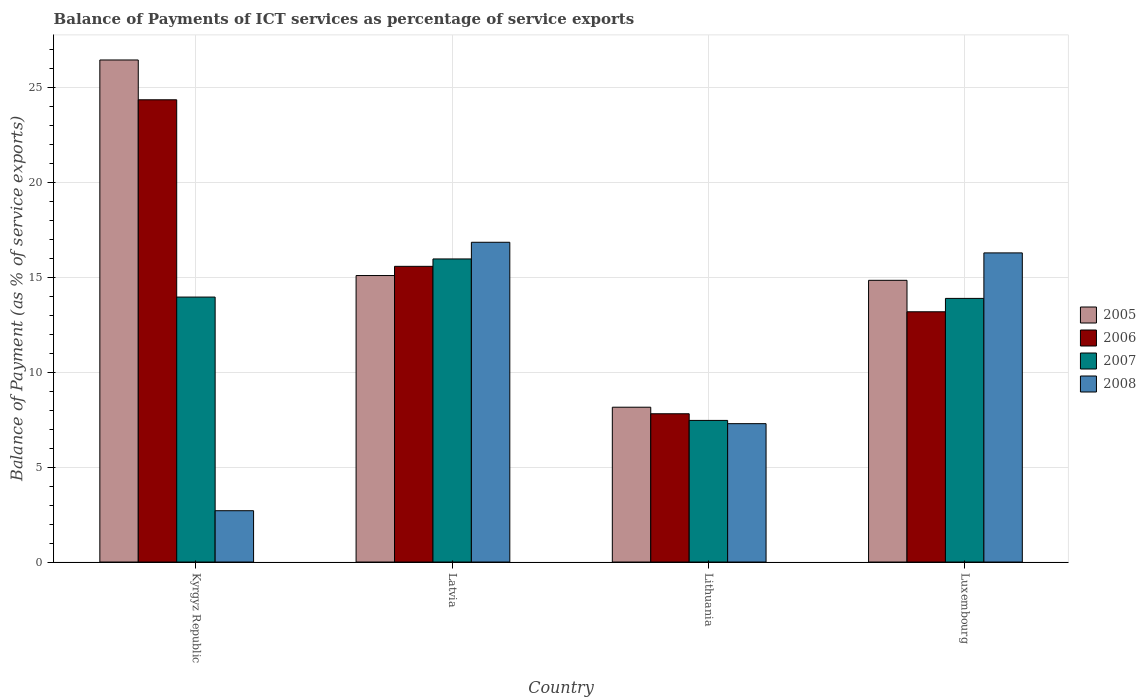How many different coloured bars are there?
Ensure brevity in your answer.  4. How many groups of bars are there?
Ensure brevity in your answer.  4. How many bars are there on the 3rd tick from the left?
Provide a short and direct response. 4. What is the label of the 1st group of bars from the left?
Provide a succinct answer. Kyrgyz Republic. What is the balance of payments of ICT services in 2007 in Lithuania?
Your answer should be very brief. 7.46. Across all countries, what is the maximum balance of payments of ICT services in 2007?
Keep it short and to the point. 15.97. Across all countries, what is the minimum balance of payments of ICT services in 2005?
Keep it short and to the point. 8.16. In which country was the balance of payments of ICT services in 2006 maximum?
Your answer should be very brief. Kyrgyz Republic. In which country was the balance of payments of ICT services in 2006 minimum?
Make the answer very short. Lithuania. What is the total balance of payments of ICT services in 2008 in the graph?
Keep it short and to the point. 43.12. What is the difference between the balance of payments of ICT services in 2007 in Kyrgyz Republic and that in Lithuania?
Your answer should be very brief. 6.5. What is the difference between the balance of payments of ICT services in 2007 in Lithuania and the balance of payments of ICT services in 2005 in Kyrgyz Republic?
Your answer should be very brief. -18.99. What is the average balance of payments of ICT services in 2008 per country?
Your answer should be very brief. 10.78. What is the difference between the balance of payments of ICT services of/in 2006 and balance of payments of ICT services of/in 2005 in Lithuania?
Ensure brevity in your answer.  -0.34. In how many countries, is the balance of payments of ICT services in 2007 greater than 26 %?
Offer a terse response. 0. What is the ratio of the balance of payments of ICT services in 2005 in Kyrgyz Republic to that in Latvia?
Make the answer very short. 1.75. Is the difference between the balance of payments of ICT services in 2006 in Kyrgyz Republic and Lithuania greater than the difference between the balance of payments of ICT services in 2005 in Kyrgyz Republic and Lithuania?
Ensure brevity in your answer.  No. What is the difference between the highest and the second highest balance of payments of ICT services in 2006?
Provide a succinct answer. 11.17. What is the difference between the highest and the lowest balance of payments of ICT services in 2007?
Offer a terse response. 8.51. In how many countries, is the balance of payments of ICT services in 2007 greater than the average balance of payments of ICT services in 2007 taken over all countries?
Give a very brief answer. 3. Is it the case that in every country, the sum of the balance of payments of ICT services in 2008 and balance of payments of ICT services in 2007 is greater than the sum of balance of payments of ICT services in 2005 and balance of payments of ICT services in 2006?
Keep it short and to the point. No. What does the 4th bar from the right in Lithuania represents?
Give a very brief answer. 2005. How many bars are there?
Make the answer very short. 16. Are all the bars in the graph horizontal?
Give a very brief answer. No. How many countries are there in the graph?
Give a very brief answer. 4. What is the difference between two consecutive major ticks on the Y-axis?
Provide a short and direct response. 5. How many legend labels are there?
Your response must be concise. 4. What is the title of the graph?
Offer a very short reply. Balance of Payments of ICT services as percentage of service exports. Does "2005" appear as one of the legend labels in the graph?
Your answer should be very brief. Yes. What is the label or title of the Y-axis?
Make the answer very short. Balance of Payment (as % of service exports). What is the Balance of Payment (as % of service exports) of 2005 in Kyrgyz Republic?
Ensure brevity in your answer.  26.45. What is the Balance of Payment (as % of service exports) in 2006 in Kyrgyz Republic?
Ensure brevity in your answer.  24.35. What is the Balance of Payment (as % of service exports) in 2007 in Kyrgyz Republic?
Your answer should be very brief. 13.96. What is the Balance of Payment (as % of service exports) of 2008 in Kyrgyz Republic?
Give a very brief answer. 2.7. What is the Balance of Payment (as % of service exports) in 2005 in Latvia?
Make the answer very short. 15.09. What is the Balance of Payment (as % of service exports) of 2006 in Latvia?
Your answer should be compact. 15.58. What is the Balance of Payment (as % of service exports) in 2007 in Latvia?
Offer a terse response. 15.97. What is the Balance of Payment (as % of service exports) in 2008 in Latvia?
Offer a terse response. 16.84. What is the Balance of Payment (as % of service exports) of 2005 in Lithuania?
Provide a short and direct response. 8.16. What is the Balance of Payment (as % of service exports) in 2006 in Lithuania?
Your response must be concise. 7.81. What is the Balance of Payment (as % of service exports) in 2007 in Lithuania?
Your answer should be very brief. 7.46. What is the Balance of Payment (as % of service exports) in 2008 in Lithuania?
Your response must be concise. 7.29. What is the Balance of Payment (as % of service exports) in 2005 in Luxembourg?
Your response must be concise. 14.84. What is the Balance of Payment (as % of service exports) of 2006 in Luxembourg?
Your response must be concise. 13.18. What is the Balance of Payment (as % of service exports) in 2007 in Luxembourg?
Offer a terse response. 13.89. What is the Balance of Payment (as % of service exports) of 2008 in Luxembourg?
Make the answer very short. 16.28. Across all countries, what is the maximum Balance of Payment (as % of service exports) of 2005?
Offer a very short reply. 26.45. Across all countries, what is the maximum Balance of Payment (as % of service exports) of 2006?
Ensure brevity in your answer.  24.35. Across all countries, what is the maximum Balance of Payment (as % of service exports) of 2007?
Give a very brief answer. 15.97. Across all countries, what is the maximum Balance of Payment (as % of service exports) in 2008?
Keep it short and to the point. 16.84. Across all countries, what is the minimum Balance of Payment (as % of service exports) of 2005?
Provide a succinct answer. 8.16. Across all countries, what is the minimum Balance of Payment (as % of service exports) of 2006?
Your response must be concise. 7.81. Across all countries, what is the minimum Balance of Payment (as % of service exports) in 2007?
Make the answer very short. 7.46. Across all countries, what is the minimum Balance of Payment (as % of service exports) of 2008?
Your answer should be compact. 2.7. What is the total Balance of Payment (as % of service exports) of 2005 in the graph?
Give a very brief answer. 64.53. What is the total Balance of Payment (as % of service exports) of 2006 in the graph?
Ensure brevity in your answer.  60.92. What is the total Balance of Payment (as % of service exports) in 2007 in the graph?
Offer a terse response. 51.27. What is the total Balance of Payment (as % of service exports) of 2008 in the graph?
Give a very brief answer. 43.12. What is the difference between the Balance of Payment (as % of service exports) in 2005 in Kyrgyz Republic and that in Latvia?
Provide a short and direct response. 11.35. What is the difference between the Balance of Payment (as % of service exports) of 2006 in Kyrgyz Republic and that in Latvia?
Offer a terse response. 8.77. What is the difference between the Balance of Payment (as % of service exports) in 2007 in Kyrgyz Republic and that in Latvia?
Ensure brevity in your answer.  -2.01. What is the difference between the Balance of Payment (as % of service exports) in 2008 in Kyrgyz Republic and that in Latvia?
Your response must be concise. -14.14. What is the difference between the Balance of Payment (as % of service exports) in 2005 in Kyrgyz Republic and that in Lithuania?
Your answer should be compact. 18.29. What is the difference between the Balance of Payment (as % of service exports) of 2006 in Kyrgyz Republic and that in Lithuania?
Your answer should be compact. 16.54. What is the difference between the Balance of Payment (as % of service exports) in 2007 in Kyrgyz Republic and that in Lithuania?
Provide a short and direct response. 6.5. What is the difference between the Balance of Payment (as % of service exports) in 2008 in Kyrgyz Republic and that in Lithuania?
Keep it short and to the point. -4.59. What is the difference between the Balance of Payment (as % of service exports) of 2005 in Kyrgyz Republic and that in Luxembourg?
Your response must be concise. 11.61. What is the difference between the Balance of Payment (as % of service exports) of 2006 in Kyrgyz Republic and that in Luxembourg?
Offer a very short reply. 11.17. What is the difference between the Balance of Payment (as % of service exports) in 2007 in Kyrgyz Republic and that in Luxembourg?
Your answer should be very brief. 0.07. What is the difference between the Balance of Payment (as % of service exports) in 2008 in Kyrgyz Republic and that in Luxembourg?
Offer a terse response. -13.58. What is the difference between the Balance of Payment (as % of service exports) in 2005 in Latvia and that in Lithuania?
Keep it short and to the point. 6.94. What is the difference between the Balance of Payment (as % of service exports) of 2006 in Latvia and that in Lithuania?
Offer a very short reply. 7.77. What is the difference between the Balance of Payment (as % of service exports) in 2007 in Latvia and that in Lithuania?
Your answer should be compact. 8.51. What is the difference between the Balance of Payment (as % of service exports) in 2008 in Latvia and that in Lithuania?
Your response must be concise. 9.55. What is the difference between the Balance of Payment (as % of service exports) in 2005 in Latvia and that in Luxembourg?
Make the answer very short. 0.25. What is the difference between the Balance of Payment (as % of service exports) of 2006 in Latvia and that in Luxembourg?
Keep it short and to the point. 2.39. What is the difference between the Balance of Payment (as % of service exports) of 2007 in Latvia and that in Luxembourg?
Your response must be concise. 2.08. What is the difference between the Balance of Payment (as % of service exports) of 2008 in Latvia and that in Luxembourg?
Your response must be concise. 0.56. What is the difference between the Balance of Payment (as % of service exports) in 2005 in Lithuania and that in Luxembourg?
Keep it short and to the point. -6.68. What is the difference between the Balance of Payment (as % of service exports) in 2006 in Lithuania and that in Luxembourg?
Your answer should be very brief. -5.37. What is the difference between the Balance of Payment (as % of service exports) of 2007 in Lithuania and that in Luxembourg?
Provide a succinct answer. -6.43. What is the difference between the Balance of Payment (as % of service exports) in 2008 in Lithuania and that in Luxembourg?
Your response must be concise. -8.99. What is the difference between the Balance of Payment (as % of service exports) of 2005 in Kyrgyz Republic and the Balance of Payment (as % of service exports) of 2006 in Latvia?
Your answer should be very brief. 10.87. What is the difference between the Balance of Payment (as % of service exports) in 2005 in Kyrgyz Republic and the Balance of Payment (as % of service exports) in 2007 in Latvia?
Your answer should be compact. 10.48. What is the difference between the Balance of Payment (as % of service exports) of 2005 in Kyrgyz Republic and the Balance of Payment (as % of service exports) of 2008 in Latvia?
Your answer should be compact. 9.6. What is the difference between the Balance of Payment (as % of service exports) in 2006 in Kyrgyz Republic and the Balance of Payment (as % of service exports) in 2007 in Latvia?
Provide a succinct answer. 8.38. What is the difference between the Balance of Payment (as % of service exports) of 2006 in Kyrgyz Republic and the Balance of Payment (as % of service exports) of 2008 in Latvia?
Ensure brevity in your answer.  7.51. What is the difference between the Balance of Payment (as % of service exports) of 2007 in Kyrgyz Republic and the Balance of Payment (as % of service exports) of 2008 in Latvia?
Ensure brevity in your answer.  -2.89. What is the difference between the Balance of Payment (as % of service exports) of 2005 in Kyrgyz Republic and the Balance of Payment (as % of service exports) of 2006 in Lithuania?
Offer a terse response. 18.64. What is the difference between the Balance of Payment (as % of service exports) of 2005 in Kyrgyz Republic and the Balance of Payment (as % of service exports) of 2007 in Lithuania?
Give a very brief answer. 18.99. What is the difference between the Balance of Payment (as % of service exports) in 2005 in Kyrgyz Republic and the Balance of Payment (as % of service exports) in 2008 in Lithuania?
Provide a succinct answer. 19.16. What is the difference between the Balance of Payment (as % of service exports) of 2006 in Kyrgyz Republic and the Balance of Payment (as % of service exports) of 2007 in Lithuania?
Keep it short and to the point. 16.89. What is the difference between the Balance of Payment (as % of service exports) of 2006 in Kyrgyz Republic and the Balance of Payment (as % of service exports) of 2008 in Lithuania?
Provide a succinct answer. 17.06. What is the difference between the Balance of Payment (as % of service exports) of 2007 in Kyrgyz Republic and the Balance of Payment (as % of service exports) of 2008 in Lithuania?
Make the answer very short. 6.67. What is the difference between the Balance of Payment (as % of service exports) in 2005 in Kyrgyz Republic and the Balance of Payment (as % of service exports) in 2006 in Luxembourg?
Make the answer very short. 13.26. What is the difference between the Balance of Payment (as % of service exports) of 2005 in Kyrgyz Republic and the Balance of Payment (as % of service exports) of 2007 in Luxembourg?
Your response must be concise. 12.56. What is the difference between the Balance of Payment (as % of service exports) of 2005 in Kyrgyz Republic and the Balance of Payment (as % of service exports) of 2008 in Luxembourg?
Provide a succinct answer. 10.16. What is the difference between the Balance of Payment (as % of service exports) of 2006 in Kyrgyz Republic and the Balance of Payment (as % of service exports) of 2007 in Luxembourg?
Offer a terse response. 10.46. What is the difference between the Balance of Payment (as % of service exports) of 2006 in Kyrgyz Republic and the Balance of Payment (as % of service exports) of 2008 in Luxembourg?
Make the answer very short. 8.07. What is the difference between the Balance of Payment (as % of service exports) of 2007 in Kyrgyz Republic and the Balance of Payment (as % of service exports) of 2008 in Luxembourg?
Offer a terse response. -2.33. What is the difference between the Balance of Payment (as % of service exports) of 2005 in Latvia and the Balance of Payment (as % of service exports) of 2006 in Lithuania?
Make the answer very short. 7.28. What is the difference between the Balance of Payment (as % of service exports) of 2005 in Latvia and the Balance of Payment (as % of service exports) of 2007 in Lithuania?
Provide a short and direct response. 7.63. What is the difference between the Balance of Payment (as % of service exports) in 2005 in Latvia and the Balance of Payment (as % of service exports) in 2008 in Lithuania?
Your answer should be compact. 7.8. What is the difference between the Balance of Payment (as % of service exports) of 2006 in Latvia and the Balance of Payment (as % of service exports) of 2007 in Lithuania?
Keep it short and to the point. 8.12. What is the difference between the Balance of Payment (as % of service exports) of 2006 in Latvia and the Balance of Payment (as % of service exports) of 2008 in Lithuania?
Make the answer very short. 8.29. What is the difference between the Balance of Payment (as % of service exports) in 2007 in Latvia and the Balance of Payment (as % of service exports) in 2008 in Lithuania?
Offer a very short reply. 8.68. What is the difference between the Balance of Payment (as % of service exports) of 2005 in Latvia and the Balance of Payment (as % of service exports) of 2006 in Luxembourg?
Your response must be concise. 1.91. What is the difference between the Balance of Payment (as % of service exports) in 2005 in Latvia and the Balance of Payment (as % of service exports) in 2007 in Luxembourg?
Give a very brief answer. 1.2. What is the difference between the Balance of Payment (as % of service exports) in 2005 in Latvia and the Balance of Payment (as % of service exports) in 2008 in Luxembourg?
Your response must be concise. -1.19. What is the difference between the Balance of Payment (as % of service exports) in 2006 in Latvia and the Balance of Payment (as % of service exports) in 2007 in Luxembourg?
Your response must be concise. 1.69. What is the difference between the Balance of Payment (as % of service exports) of 2006 in Latvia and the Balance of Payment (as % of service exports) of 2008 in Luxembourg?
Your answer should be very brief. -0.71. What is the difference between the Balance of Payment (as % of service exports) of 2007 in Latvia and the Balance of Payment (as % of service exports) of 2008 in Luxembourg?
Your answer should be very brief. -0.32. What is the difference between the Balance of Payment (as % of service exports) of 2005 in Lithuania and the Balance of Payment (as % of service exports) of 2006 in Luxembourg?
Provide a short and direct response. -5.03. What is the difference between the Balance of Payment (as % of service exports) of 2005 in Lithuania and the Balance of Payment (as % of service exports) of 2007 in Luxembourg?
Offer a terse response. -5.73. What is the difference between the Balance of Payment (as % of service exports) of 2005 in Lithuania and the Balance of Payment (as % of service exports) of 2008 in Luxembourg?
Give a very brief answer. -8.13. What is the difference between the Balance of Payment (as % of service exports) in 2006 in Lithuania and the Balance of Payment (as % of service exports) in 2007 in Luxembourg?
Ensure brevity in your answer.  -6.08. What is the difference between the Balance of Payment (as % of service exports) of 2006 in Lithuania and the Balance of Payment (as % of service exports) of 2008 in Luxembourg?
Your answer should be very brief. -8.47. What is the difference between the Balance of Payment (as % of service exports) in 2007 in Lithuania and the Balance of Payment (as % of service exports) in 2008 in Luxembourg?
Make the answer very short. -8.82. What is the average Balance of Payment (as % of service exports) of 2005 per country?
Provide a succinct answer. 16.13. What is the average Balance of Payment (as % of service exports) of 2006 per country?
Ensure brevity in your answer.  15.23. What is the average Balance of Payment (as % of service exports) in 2007 per country?
Your answer should be compact. 12.82. What is the average Balance of Payment (as % of service exports) in 2008 per country?
Offer a very short reply. 10.78. What is the difference between the Balance of Payment (as % of service exports) in 2005 and Balance of Payment (as % of service exports) in 2006 in Kyrgyz Republic?
Offer a very short reply. 2.1. What is the difference between the Balance of Payment (as % of service exports) in 2005 and Balance of Payment (as % of service exports) in 2007 in Kyrgyz Republic?
Offer a very short reply. 12.49. What is the difference between the Balance of Payment (as % of service exports) of 2005 and Balance of Payment (as % of service exports) of 2008 in Kyrgyz Republic?
Make the answer very short. 23.74. What is the difference between the Balance of Payment (as % of service exports) in 2006 and Balance of Payment (as % of service exports) in 2007 in Kyrgyz Republic?
Keep it short and to the point. 10.39. What is the difference between the Balance of Payment (as % of service exports) of 2006 and Balance of Payment (as % of service exports) of 2008 in Kyrgyz Republic?
Your answer should be very brief. 21.65. What is the difference between the Balance of Payment (as % of service exports) of 2007 and Balance of Payment (as % of service exports) of 2008 in Kyrgyz Republic?
Ensure brevity in your answer.  11.25. What is the difference between the Balance of Payment (as % of service exports) of 2005 and Balance of Payment (as % of service exports) of 2006 in Latvia?
Offer a terse response. -0.48. What is the difference between the Balance of Payment (as % of service exports) in 2005 and Balance of Payment (as % of service exports) in 2007 in Latvia?
Ensure brevity in your answer.  -0.87. What is the difference between the Balance of Payment (as % of service exports) in 2005 and Balance of Payment (as % of service exports) in 2008 in Latvia?
Keep it short and to the point. -1.75. What is the difference between the Balance of Payment (as % of service exports) of 2006 and Balance of Payment (as % of service exports) of 2007 in Latvia?
Offer a very short reply. -0.39. What is the difference between the Balance of Payment (as % of service exports) in 2006 and Balance of Payment (as % of service exports) in 2008 in Latvia?
Ensure brevity in your answer.  -1.27. What is the difference between the Balance of Payment (as % of service exports) of 2007 and Balance of Payment (as % of service exports) of 2008 in Latvia?
Give a very brief answer. -0.88. What is the difference between the Balance of Payment (as % of service exports) of 2005 and Balance of Payment (as % of service exports) of 2006 in Lithuania?
Your answer should be very brief. 0.34. What is the difference between the Balance of Payment (as % of service exports) in 2005 and Balance of Payment (as % of service exports) in 2007 in Lithuania?
Offer a very short reply. 0.7. What is the difference between the Balance of Payment (as % of service exports) in 2005 and Balance of Payment (as % of service exports) in 2008 in Lithuania?
Provide a succinct answer. 0.87. What is the difference between the Balance of Payment (as % of service exports) in 2006 and Balance of Payment (as % of service exports) in 2007 in Lithuania?
Make the answer very short. 0.35. What is the difference between the Balance of Payment (as % of service exports) in 2006 and Balance of Payment (as % of service exports) in 2008 in Lithuania?
Make the answer very short. 0.52. What is the difference between the Balance of Payment (as % of service exports) of 2007 and Balance of Payment (as % of service exports) of 2008 in Lithuania?
Provide a succinct answer. 0.17. What is the difference between the Balance of Payment (as % of service exports) in 2005 and Balance of Payment (as % of service exports) in 2006 in Luxembourg?
Offer a very short reply. 1.66. What is the difference between the Balance of Payment (as % of service exports) in 2005 and Balance of Payment (as % of service exports) in 2007 in Luxembourg?
Your answer should be very brief. 0.95. What is the difference between the Balance of Payment (as % of service exports) in 2005 and Balance of Payment (as % of service exports) in 2008 in Luxembourg?
Offer a terse response. -1.44. What is the difference between the Balance of Payment (as % of service exports) in 2006 and Balance of Payment (as % of service exports) in 2007 in Luxembourg?
Your answer should be compact. -0.7. What is the difference between the Balance of Payment (as % of service exports) of 2006 and Balance of Payment (as % of service exports) of 2008 in Luxembourg?
Keep it short and to the point. -3.1. What is the difference between the Balance of Payment (as % of service exports) in 2007 and Balance of Payment (as % of service exports) in 2008 in Luxembourg?
Offer a very short reply. -2.4. What is the ratio of the Balance of Payment (as % of service exports) in 2005 in Kyrgyz Republic to that in Latvia?
Offer a very short reply. 1.75. What is the ratio of the Balance of Payment (as % of service exports) in 2006 in Kyrgyz Republic to that in Latvia?
Your answer should be very brief. 1.56. What is the ratio of the Balance of Payment (as % of service exports) in 2007 in Kyrgyz Republic to that in Latvia?
Your answer should be very brief. 0.87. What is the ratio of the Balance of Payment (as % of service exports) in 2008 in Kyrgyz Republic to that in Latvia?
Ensure brevity in your answer.  0.16. What is the ratio of the Balance of Payment (as % of service exports) of 2005 in Kyrgyz Republic to that in Lithuania?
Give a very brief answer. 3.24. What is the ratio of the Balance of Payment (as % of service exports) in 2006 in Kyrgyz Republic to that in Lithuania?
Offer a terse response. 3.12. What is the ratio of the Balance of Payment (as % of service exports) in 2007 in Kyrgyz Republic to that in Lithuania?
Ensure brevity in your answer.  1.87. What is the ratio of the Balance of Payment (as % of service exports) of 2008 in Kyrgyz Republic to that in Lithuania?
Keep it short and to the point. 0.37. What is the ratio of the Balance of Payment (as % of service exports) of 2005 in Kyrgyz Republic to that in Luxembourg?
Give a very brief answer. 1.78. What is the ratio of the Balance of Payment (as % of service exports) of 2006 in Kyrgyz Republic to that in Luxembourg?
Your answer should be compact. 1.85. What is the ratio of the Balance of Payment (as % of service exports) in 2007 in Kyrgyz Republic to that in Luxembourg?
Keep it short and to the point. 1. What is the ratio of the Balance of Payment (as % of service exports) in 2008 in Kyrgyz Republic to that in Luxembourg?
Offer a terse response. 0.17. What is the ratio of the Balance of Payment (as % of service exports) of 2005 in Latvia to that in Lithuania?
Offer a very short reply. 1.85. What is the ratio of the Balance of Payment (as % of service exports) of 2006 in Latvia to that in Lithuania?
Your answer should be compact. 1.99. What is the ratio of the Balance of Payment (as % of service exports) in 2007 in Latvia to that in Lithuania?
Offer a terse response. 2.14. What is the ratio of the Balance of Payment (as % of service exports) in 2008 in Latvia to that in Lithuania?
Give a very brief answer. 2.31. What is the ratio of the Balance of Payment (as % of service exports) in 2005 in Latvia to that in Luxembourg?
Provide a short and direct response. 1.02. What is the ratio of the Balance of Payment (as % of service exports) in 2006 in Latvia to that in Luxembourg?
Give a very brief answer. 1.18. What is the ratio of the Balance of Payment (as % of service exports) of 2007 in Latvia to that in Luxembourg?
Your response must be concise. 1.15. What is the ratio of the Balance of Payment (as % of service exports) of 2008 in Latvia to that in Luxembourg?
Your answer should be very brief. 1.03. What is the ratio of the Balance of Payment (as % of service exports) in 2005 in Lithuania to that in Luxembourg?
Offer a very short reply. 0.55. What is the ratio of the Balance of Payment (as % of service exports) of 2006 in Lithuania to that in Luxembourg?
Keep it short and to the point. 0.59. What is the ratio of the Balance of Payment (as % of service exports) in 2007 in Lithuania to that in Luxembourg?
Your response must be concise. 0.54. What is the ratio of the Balance of Payment (as % of service exports) in 2008 in Lithuania to that in Luxembourg?
Offer a very short reply. 0.45. What is the difference between the highest and the second highest Balance of Payment (as % of service exports) of 2005?
Ensure brevity in your answer.  11.35. What is the difference between the highest and the second highest Balance of Payment (as % of service exports) in 2006?
Offer a very short reply. 8.77. What is the difference between the highest and the second highest Balance of Payment (as % of service exports) in 2007?
Your answer should be very brief. 2.01. What is the difference between the highest and the second highest Balance of Payment (as % of service exports) of 2008?
Offer a terse response. 0.56. What is the difference between the highest and the lowest Balance of Payment (as % of service exports) in 2005?
Keep it short and to the point. 18.29. What is the difference between the highest and the lowest Balance of Payment (as % of service exports) in 2006?
Offer a very short reply. 16.54. What is the difference between the highest and the lowest Balance of Payment (as % of service exports) in 2007?
Give a very brief answer. 8.51. What is the difference between the highest and the lowest Balance of Payment (as % of service exports) of 2008?
Offer a very short reply. 14.14. 